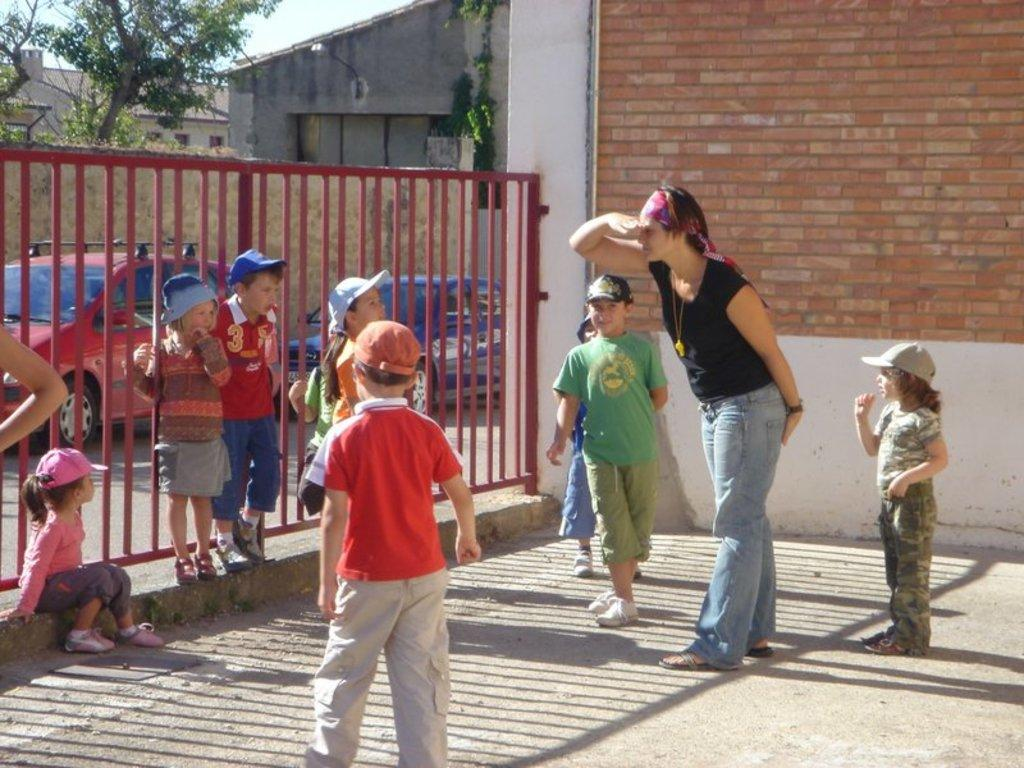What is the main subject in the center of the image? There are kids in the center of the image. Who else can be seen in the image? There is a lady standing on the right side of the image. What is the purpose of the structure in the image? There is a fence in the image, which may serve as a boundary or barrier. What type of vehicles are present in the image? There are cars in the image. What can be seen in the background of the image? There are sheds, trees, and the sky visible in the background of the image. What type of pollution is visible in the image? There is no indication of pollution in the image. Is there any visible expression of hate in the image? There is no visible expression of hate in the image. 